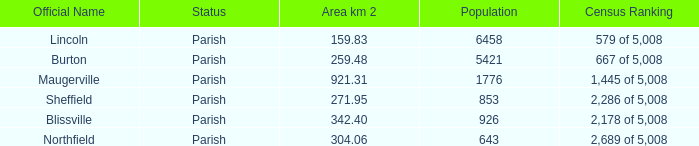What is the status(es) of the place with an area of 304.06 km2? Parish. 